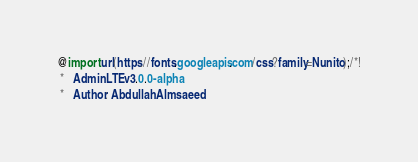<code> <loc_0><loc_0><loc_500><loc_500><_CSS_>@import url(https://fonts.googleapis.com/css?family=Nunito);/*!
 *   AdminLTE v3.0.0-alpha
 *   Author: Abdullah Almsaeed</code> 